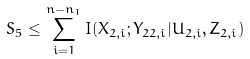Convert formula to latex. <formula><loc_0><loc_0><loc_500><loc_500>S _ { 5 } \leq \sum _ { i = 1 } ^ { n - n _ { 1 } } I ( X _ { 2 , i } ; Y _ { 2 2 , i } | U _ { 2 , i } , Z _ { 2 , i } )</formula> 